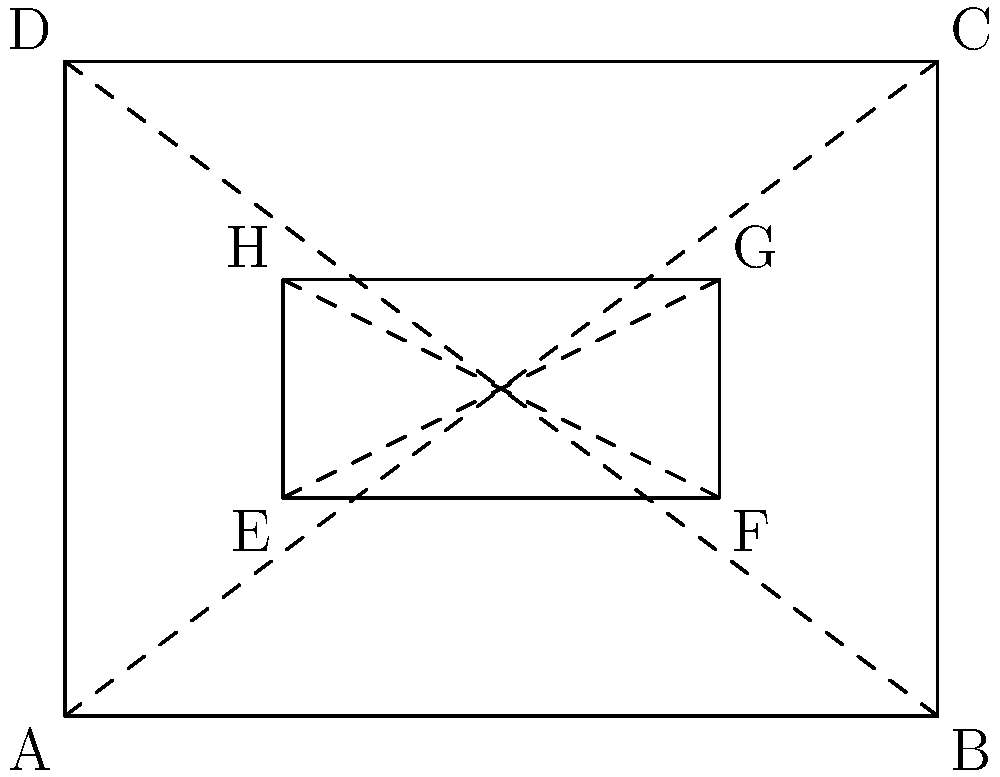Your college basketball team is designing a new logo. The outer rectangle ABCD represents the full logo, while the inner rectangle EFGH is a key element. If AB = 4 units, BC = 3 units, and EF = 2 units, prove that triangles AED and CGH are congruent. How could this property be useful in logo design for uniform printing? Let's prove the congruence of triangles AED and CGH step by step:

1) In rectangle ABCD:
   - AB is parallel to DC (opposite sides of a rectangle)
   - AD is parallel to BC (opposite sides of a rectangle)

2) In rectangle EFGH:
   - EF is parallel to HG (opposite sides of a rectangle)
   - EH is parallel to FG (opposite sides of a rectangle)

3) From the given information:
   - AB = 4 units, BC = 3 units, EF = 2 units

4) Let's consider triangle AED:
   - AE = 1 unit (since E is 1 unit from A)
   - AD = 3 units (height of the outer rectangle)
   - Angle EAD = 90° (right angle of the outer rectangle)

5) Now, consider triangle CGH:
   - CG = 1 unit (since G is 1 unit from C)
   - CH = 3 units (height of the outer rectangle)
   - Angle GCH = 90° (right angle of the outer rectangle)

6) Comparing the two triangles:
   - AE = CG (both equal to 1 unit)
   - AD = CH (both equal to 3 units)
   - Angle EAD = Angle GCH (both are 90°)

7) By the AAS (Angle-Angle-Side) congruence criterion, if two angles and a non-included side of one triangle are equal to the corresponding parts of another triangle, the triangles are congruent.

Therefore, triangles AED and CGH are congruent.

This property could be useful in logo design for uniform printing because:
- It ensures symmetry in the logo design
- It allows for consistent scaling of the logo while maintaining proportions
- It can be used to create mirror images or rotations of design elements, which is often desirable in sports logos
Answer: Triangles AED and CGH are congruent by AAS criterion (AE=CG, AD=CH, ∠EAD=∠GCH=90°). 